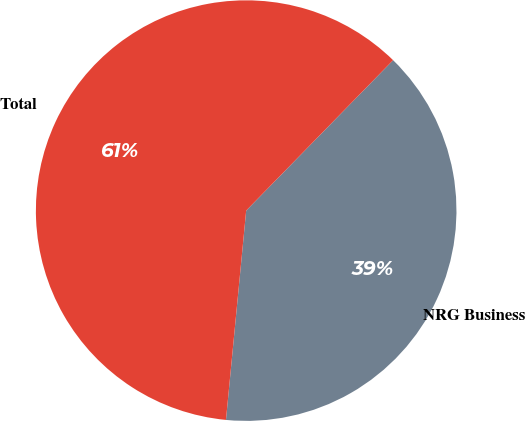Convert chart to OTSL. <chart><loc_0><loc_0><loc_500><loc_500><pie_chart><fcel>NRG Business<fcel>Total<nl><fcel>39.22%<fcel>60.78%<nl></chart> 